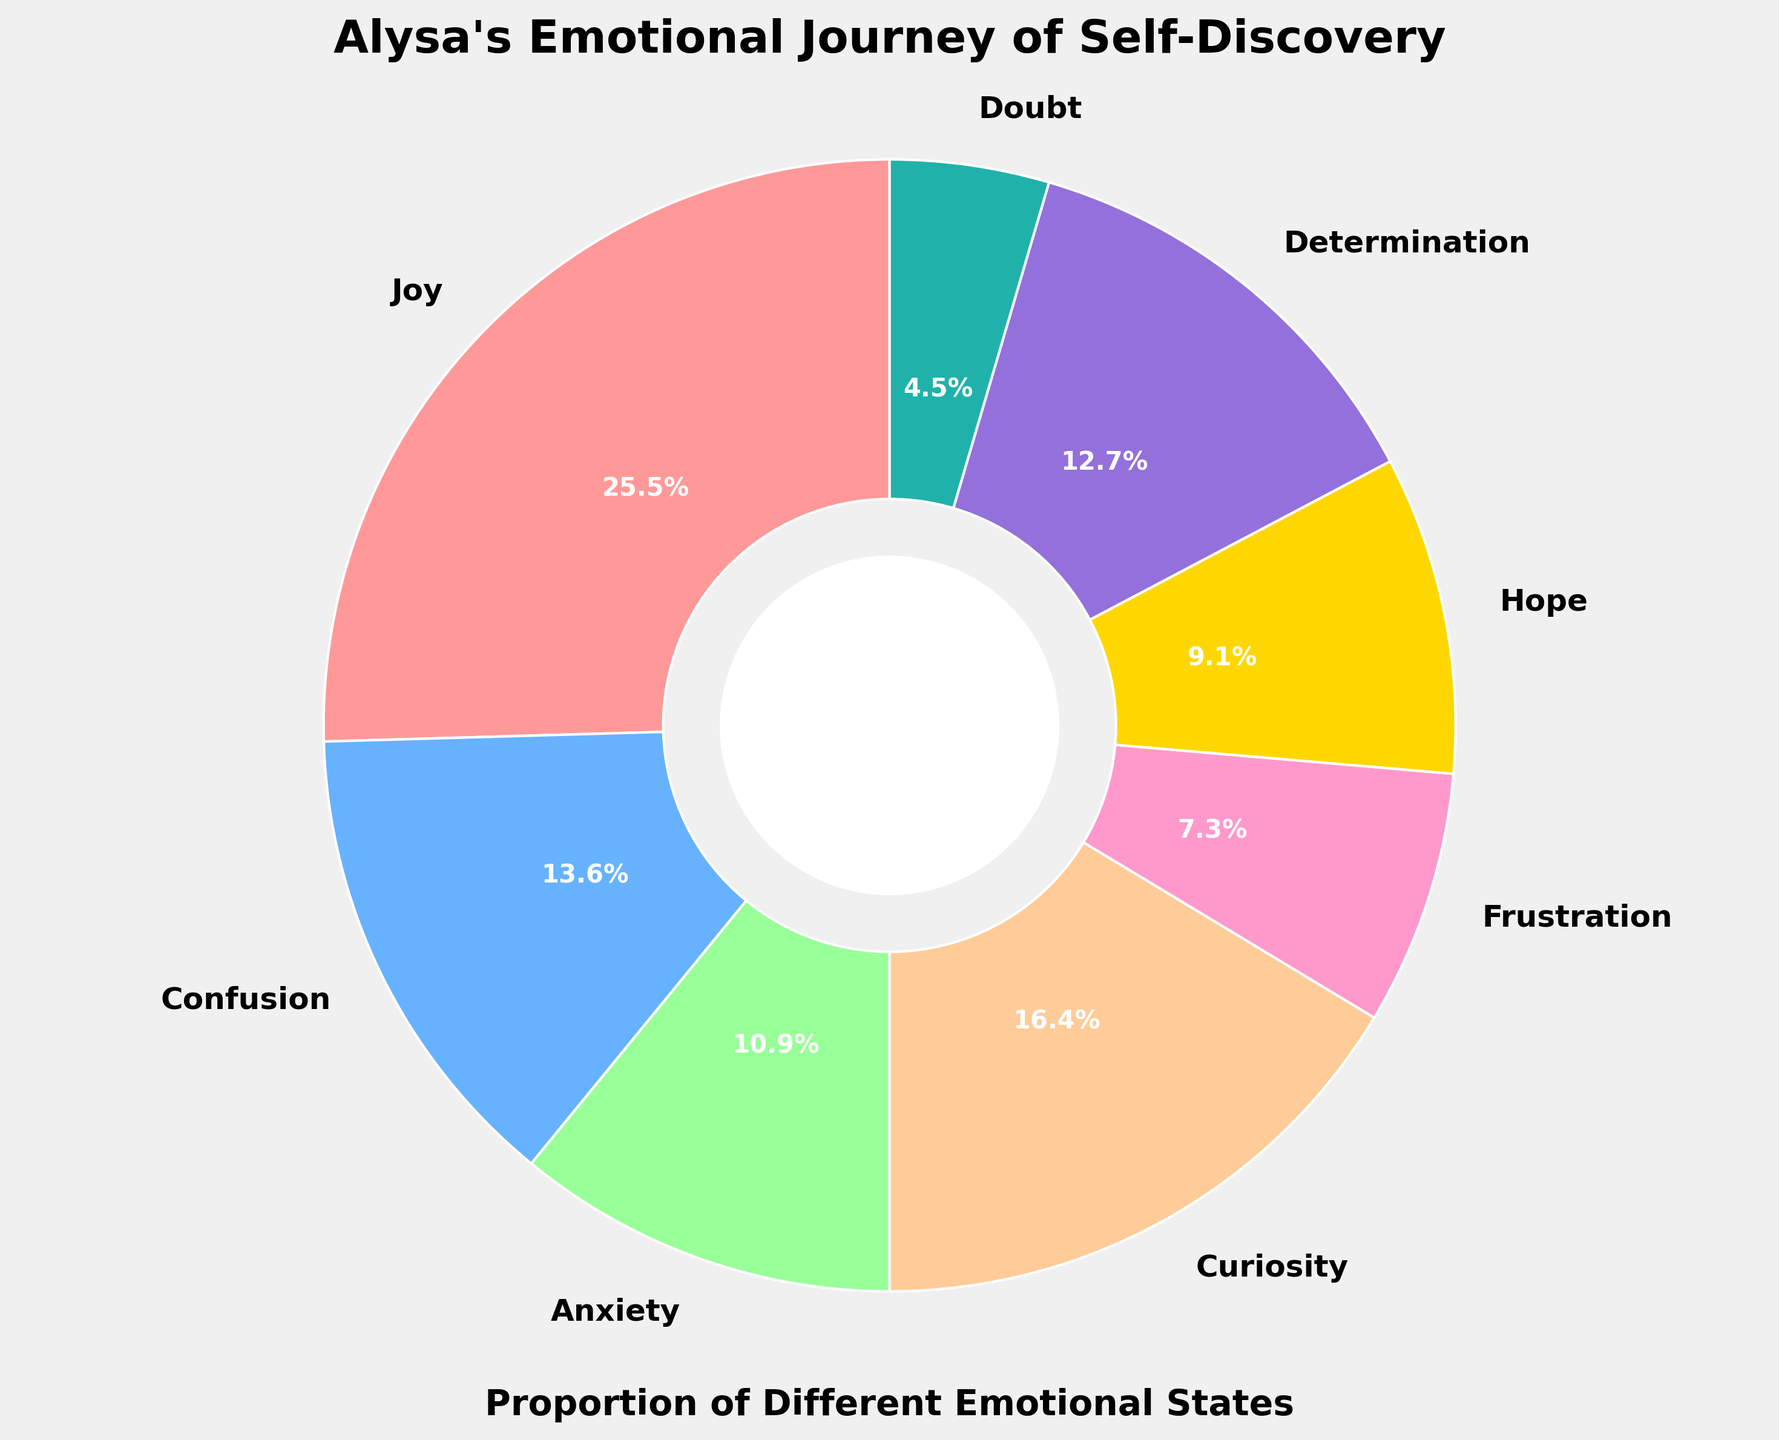what is the largest emotional state by percentage in Alysa's journey? The largest percentage is 28% and corresponds to the emotion 'Joy'. This can be observed by identifying the segment of the pie chart with the largest area, which is labeled 'Joy'.
Answer: Joy Which emotion has the smallest proportion in Alysa's journey and what is its percentage? The smallest percentage is 5% and corresponds to the emotion 'Doubt'. You can find this by identifying the segment of the pie chart with the smallest area, which is labeled 'Doubt'.
Answer: Doubt, 5% What is the combined percentage of Joy and Curiosity? Joy is 28% and Curiosity is 18%. Adding these two percentages together results in 28%+18%=46%.
Answer: 46% Is the sum of percentages of Anxiety and Determination greater than the percentage of Joy? Anxiety is 12% and Determination is 14%, which together make up 12%+14%=26%. Comparing this sum with Joy's percentage of 28%, 26% is less than 28%.
Answer: No Which emotion has a higher percentage in Alysa's journey: Hope or Frustration, and by how much? Hope has a percentage of 10%, and Frustration has a percentage of 8%. The difference is 10%-8%=2%. Therefore, Hope is higher by 2%.
Answer: Hope, by 2% What are the total percentages of positive emotions (Joy, Hope, Determination) in Alysa's journey? Joy is 28%, Hope is 10%, and Determination is 14%. Adding these positive emotions together results in 28%+10%+14%=52%.
Answer: 52% Compare if the proportion of Confusion is closer to the proportion of Determination or Anxiety? Confusion is 15%, Determination is 14%, and Anxiety is 12%. The difference between Confusion and Determination is 15%-14%=1%, and the difference between Confusion and Anxiety is 15%-12%=3%. Thus, Confusion is closer to Determination.
Answer: Determination How does the proportion of Anxiety compare to the total proportion of Curiosity and Frustration? Anxiety is 12%, Curiosity is 18%, and Frustration is 8%. The total proportion of Curiosity and Frustration is 18%+8%=26%. Comparing this with Anxiety’s 12%, 12% is less than 26%.
Answer: Less What is the difference between the proportions of Joy and Confusion? Joy has a proportion of 28%, and Confusion has a proportion of 15%. The difference is 28%-15%=13%.
Answer: 13% If Alysa's feelings of Doubt doubled, what would its new proportion be and how does it affect the total percentage? Doubling the proportion of Doubt means 5%*2 = 10%. Since the total must still add to 100%, increasing Doubt to 10% would require reducing another emotion by 5% or adjusting multiple emotions to cumulatively decrease by 5%.
Answer: 10%, total percentage remains 100% 